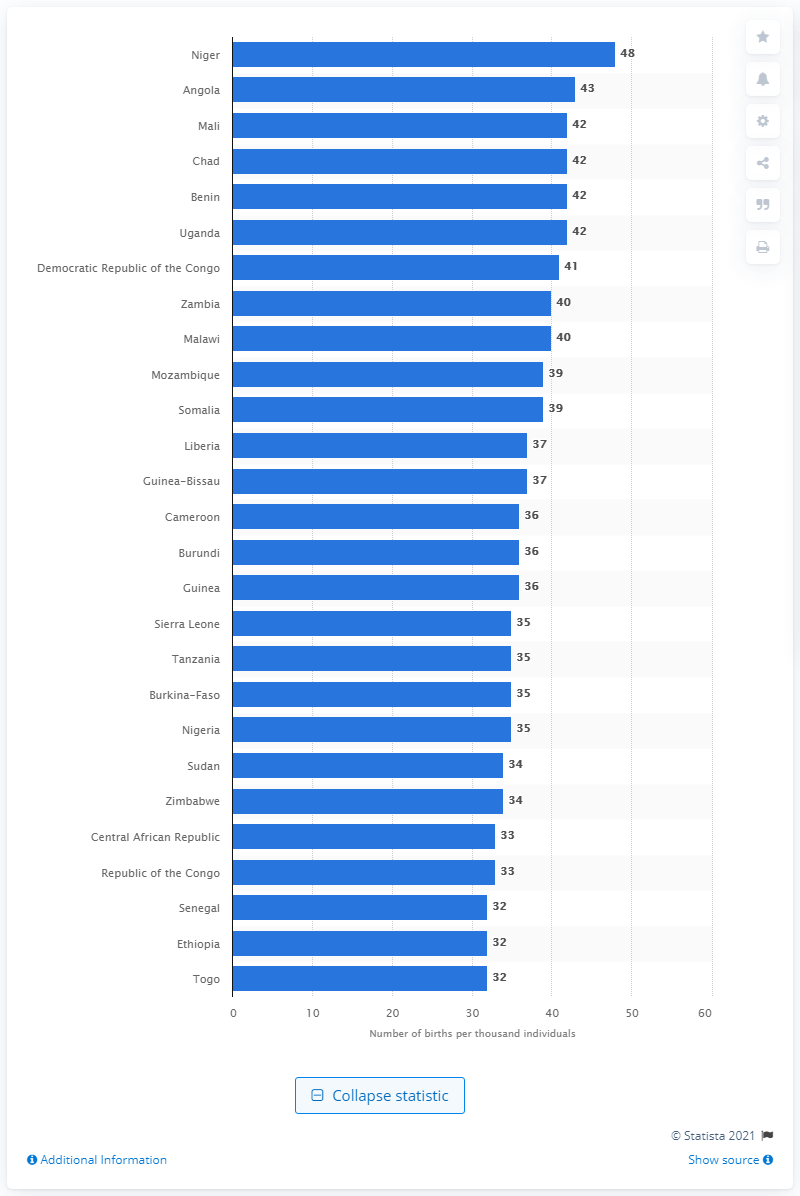Draw attention to some important aspects in this diagram. The birth rate in Mali, Chad, Benin, and Uganda was 42 In 2020, there were approximately 43 births per 1,000 inhabitants in Angola. In 2020, there were 48 births per 1,000 inhabitants in Niger. 